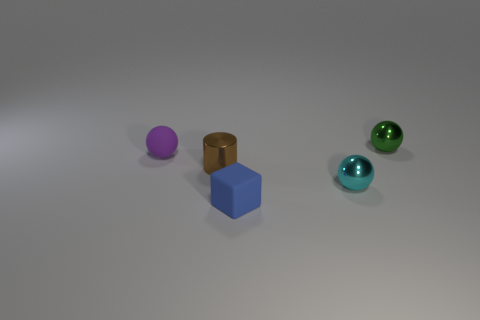Are there any other things that have the same shape as the brown object?
Offer a very short reply. No. Is the number of small blue blocks right of the tiny cyan sphere the same as the number of cyan cylinders?
Provide a succinct answer. Yes. How many tiny objects have the same material as the blue block?
Give a very brief answer. 1. There is a tiny sphere that is the same material as the blue block; what is its color?
Offer a very short reply. Purple. Is the shape of the small purple rubber thing the same as the green thing?
Give a very brief answer. Yes. Are there any balls that are behind the tiny metallic ball that is in front of the sphere that is behind the small purple matte object?
Your response must be concise. Yes. What shape is the cyan metal thing that is the same size as the green object?
Your answer should be very brief. Sphere. There is a brown shiny object; are there any tiny objects right of it?
Your answer should be very brief. Yes. Does the brown metal thing have the same size as the purple ball?
Offer a terse response. Yes. What shape is the small shiny thing that is behind the rubber sphere?
Offer a very short reply. Sphere. 